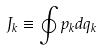<formula> <loc_0><loc_0><loc_500><loc_500>J _ { k } \equiv \oint p _ { k } d q _ { k }</formula> 